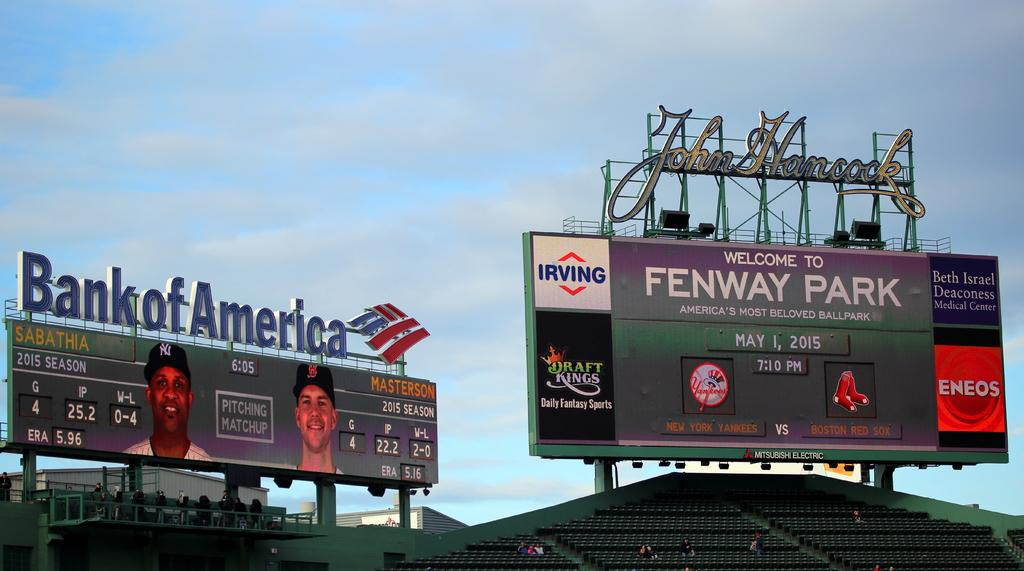<image>
Give a short and clear explanation of the subsequent image. Two billboards with advertisments for bank of america and irving. 